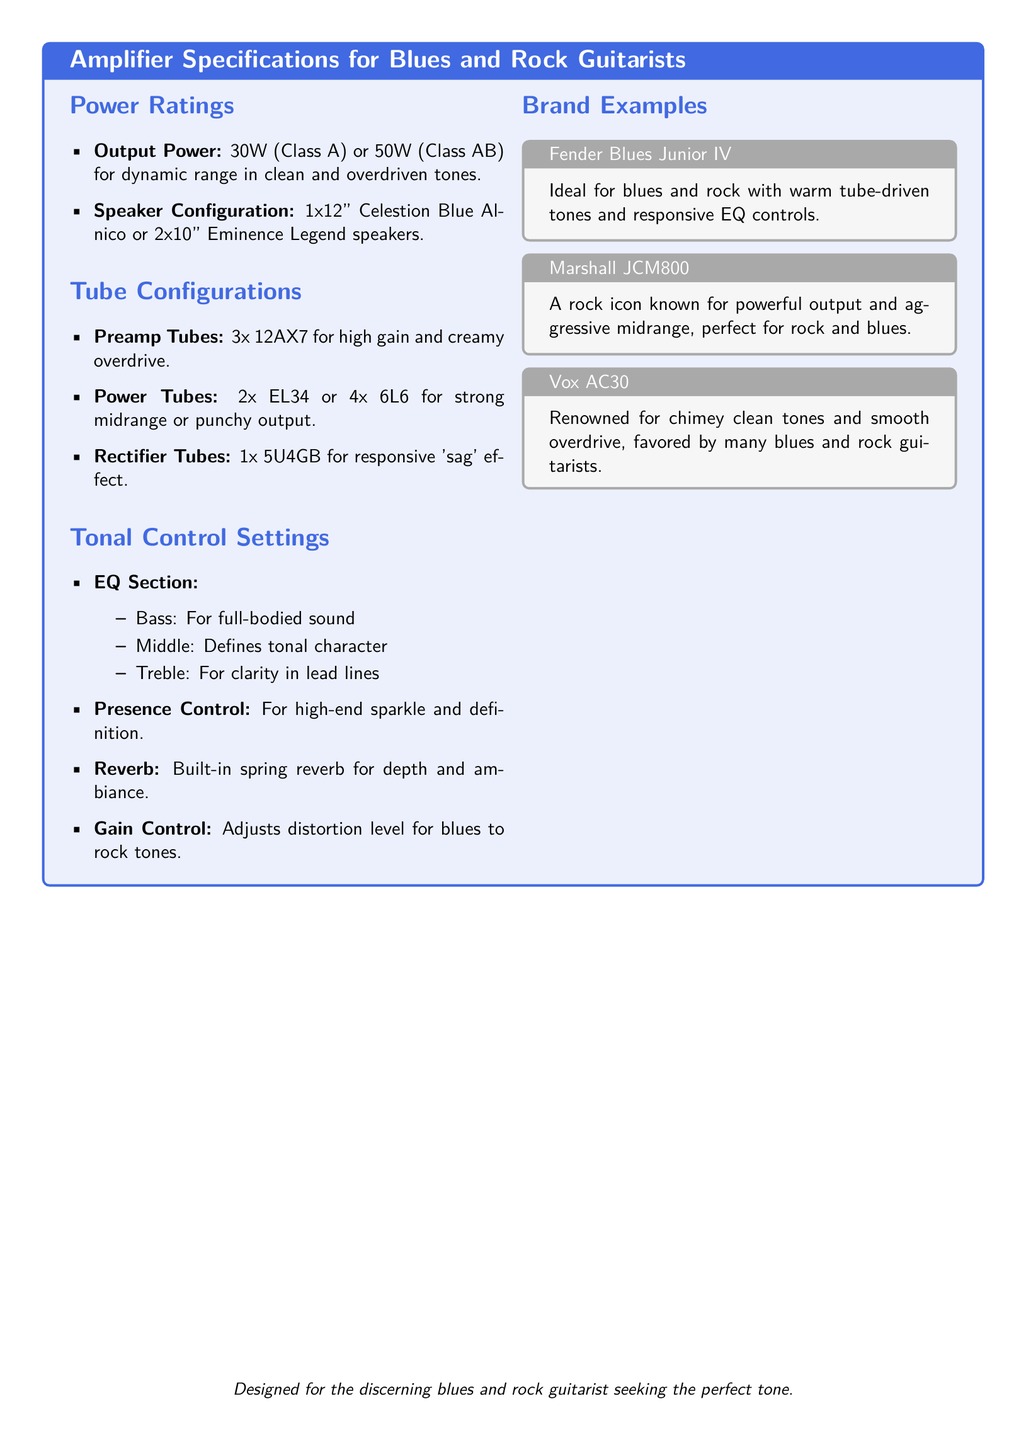what is the output power for the amplifier? The output power is specified as either 30W (Class A) or 50W (Class AB) in the document.
Answer: 30W (Class A) or 50W (Class AB) what type of speaker configuration is mentioned? The document lists speaker configurations, specifically mentioning "1x12" Celestion Blue Alnico or 2x10" Eminence Legend speakers."
Answer: 1x12" Celestion Blue Alnico or 2x10" Eminence Legend how many preamp tubes are used in the amplifier? The amplifier specifications indicate that it uses 3x 12AX7 preamp tubes for high gain and creamy overdrive.
Answer: 3x 12AX7 which tube is used for the 'sag' effect? The document specifies that 1x 5U4GB is the tube used for the responsive 'sag' effect.
Answer: 1x 5U4GB what is the purpose of the gain control? The gain control adjusts the distortion level for blues to rock tones, as explained in the tonal control section.
Answer: Adjusts distortion level what is the reverb type featured in the amplifier? According to the tonal control settings, the amplifier features a built-in spring reverb for depth and ambiance.
Answer: Built-in spring reverb which brand is associated with warm tube-driven tones for blues and rock? The document mentions the Fender Blues Junior IV as ideal for blues and rock with warm tube-driven tones.
Answer: Fender Blues Junior IV what is the significance of the presence control? The presence control is described in the document as providing high-end sparkle and definition, impacting the overall tone.
Answer: High-end sparkle and definition how many power tubes can the amplifier have? The amplifier can have either 2x EL34 or 4x 6L6 power tubes, providing options for strong midrange or punchy output.
Answer: 2x EL34 or 4x 6L6 